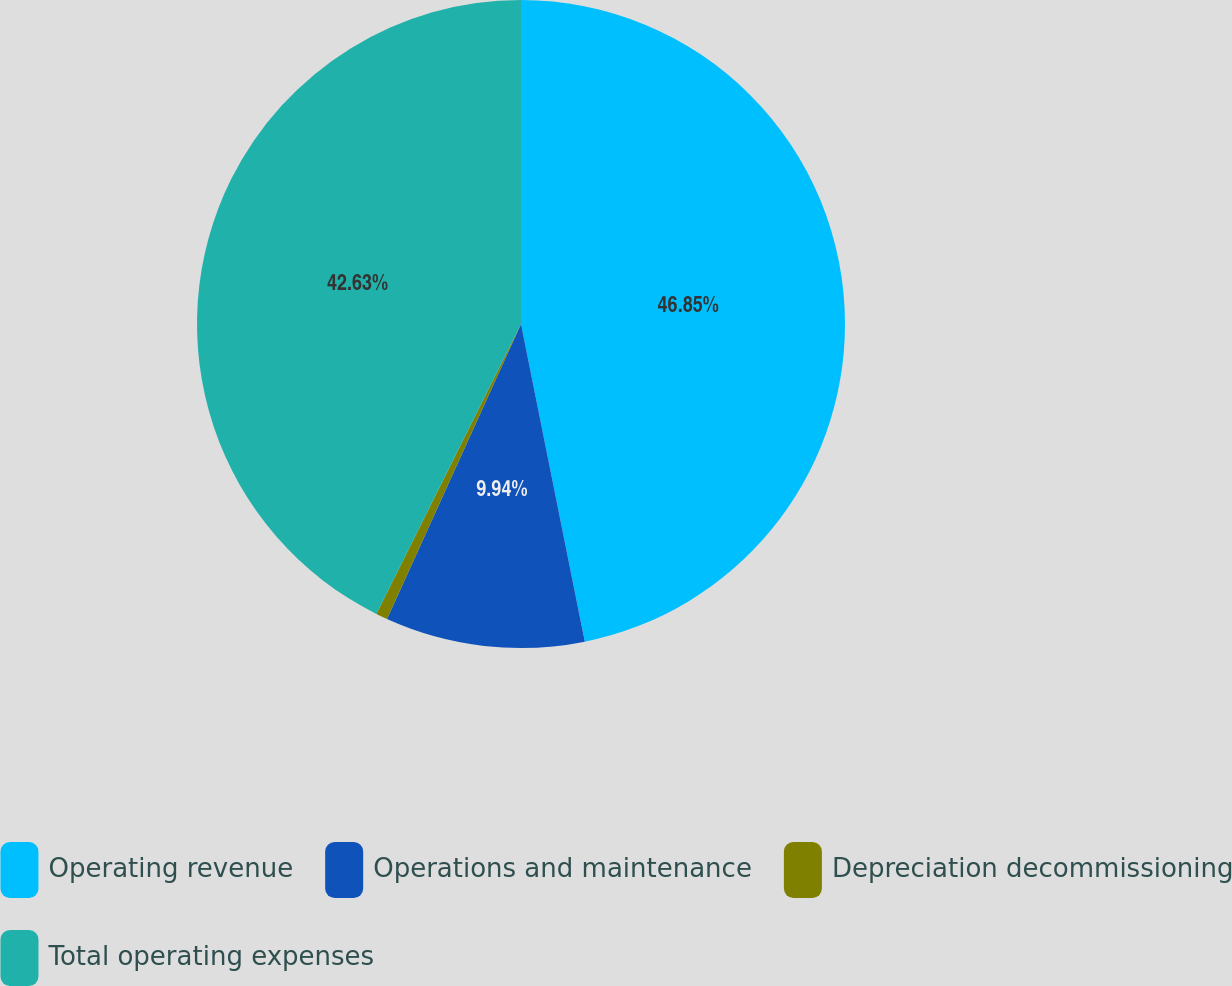<chart> <loc_0><loc_0><loc_500><loc_500><pie_chart><fcel>Operating revenue<fcel>Operations and maintenance<fcel>Depreciation decommissioning<fcel>Total operating expenses<nl><fcel>46.84%<fcel>9.94%<fcel>0.58%<fcel>42.63%<nl></chart> 